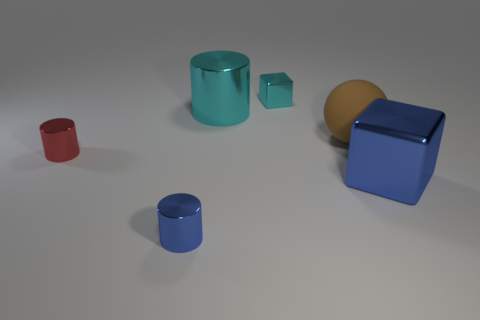There is a tiny metallic thing in front of the large blue metal block; what is its shape?
Your response must be concise. Cylinder. Is there any other thing of the same color as the matte object?
Make the answer very short. No. Are there fewer tiny blocks that are on the right side of the brown object than tiny cylinders?
Provide a short and direct response. Yes. What number of blue cubes are the same size as the red object?
Provide a short and direct response. 0. What shape is the tiny object that is the same color as the large block?
Your answer should be very brief. Cylinder. The metal thing to the right of the small object that is to the right of the cylinder that is in front of the blue cube is what shape?
Your response must be concise. Cube. There is a large metallic object behind the big blue cube; what is its color?
Give a very brief answer. Cyan. How many objects are cubes in front of the small red metallic thing or metallic cubes that are in front of the cyan shiny cylinder?
Give a very brief answer. 1. How many other big rubber objects are the same shape as the big brown thing?
Keep it short and to the point. 0. What color is the matte object that is the same size as the blue shiny cube?
Your answer should be very brief. Brown. 